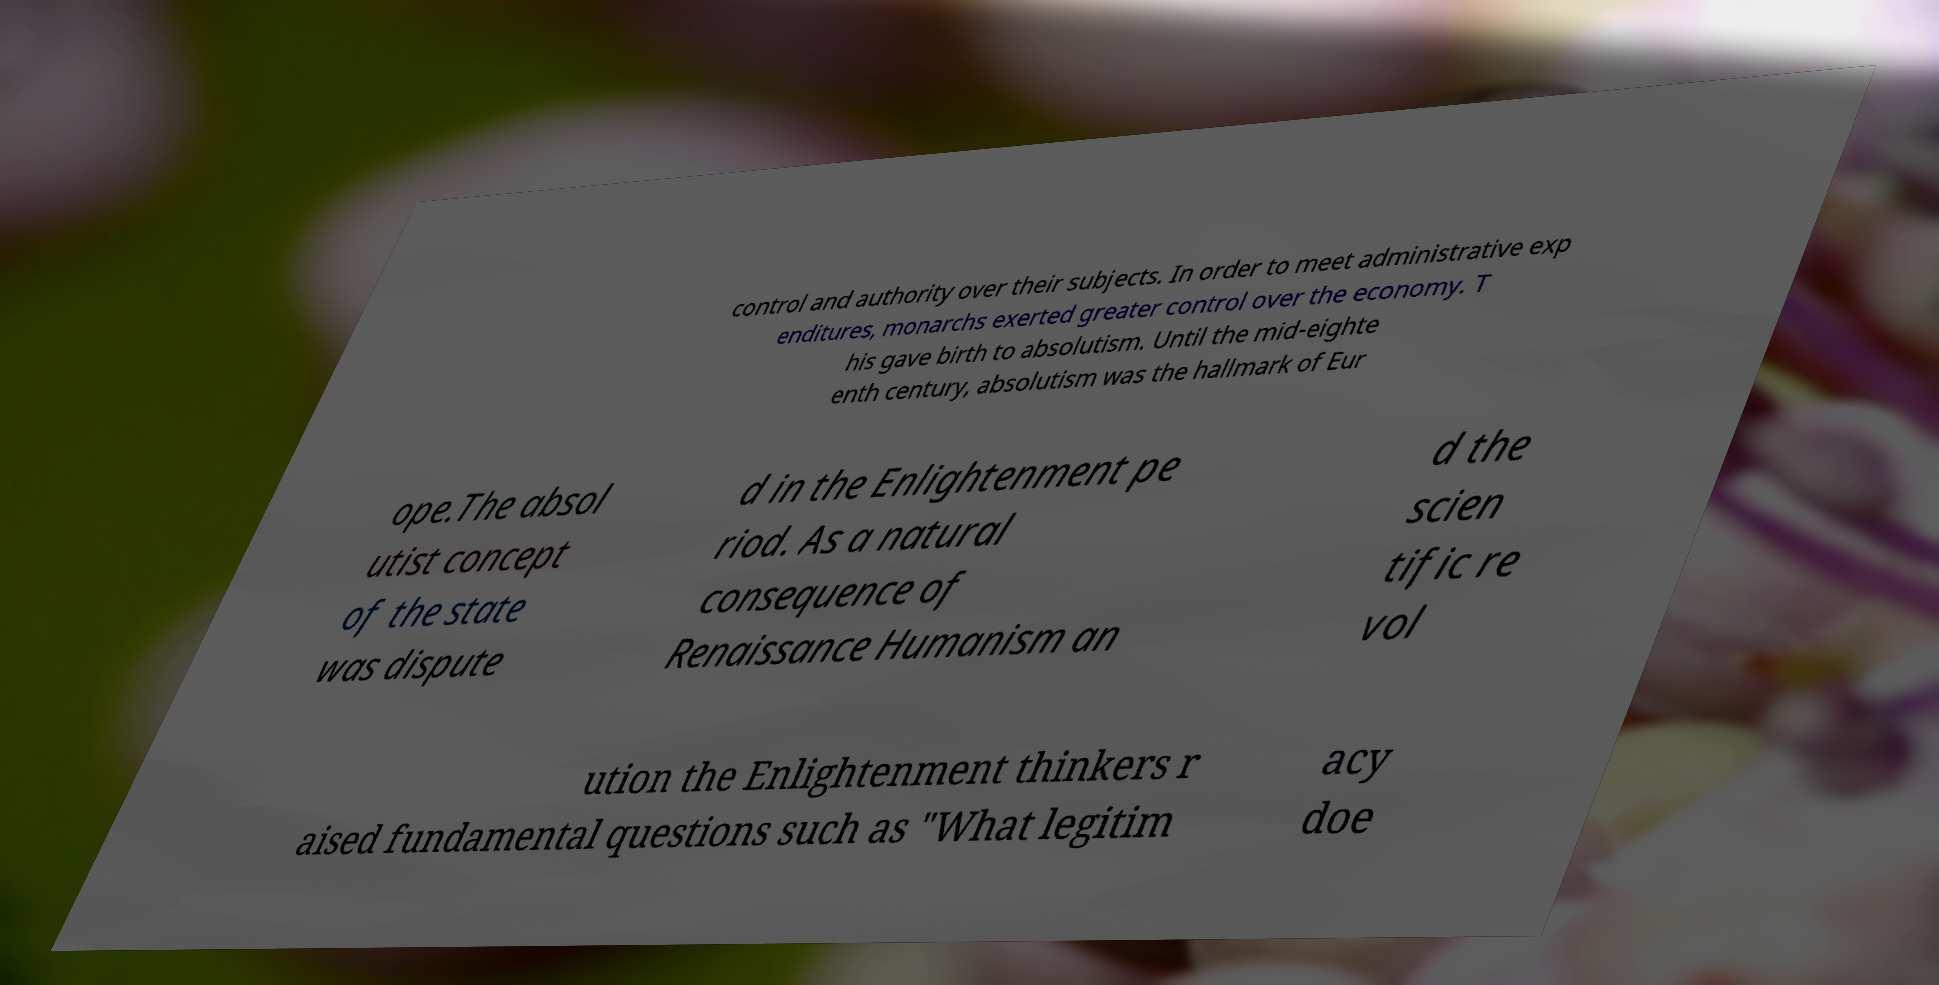Could you assist in decoding the text presented in this image and type it out clearly? control and authority over their subjects. In order to meet administrative exp enditures, monarchs exerted greater control over the economy. T his gave birth to absolutism. Until the mid-eighte enth century, absolutism was the hallmark of Eur ope.The absol utist concept of the state was dispute d in the Enlightenment pe riod. As a natural consequence of Renaissance Humanism an d the scien tific re vol ution the Enlightenment thinkers r aised fundamental questions such as "What legitim acy doe 